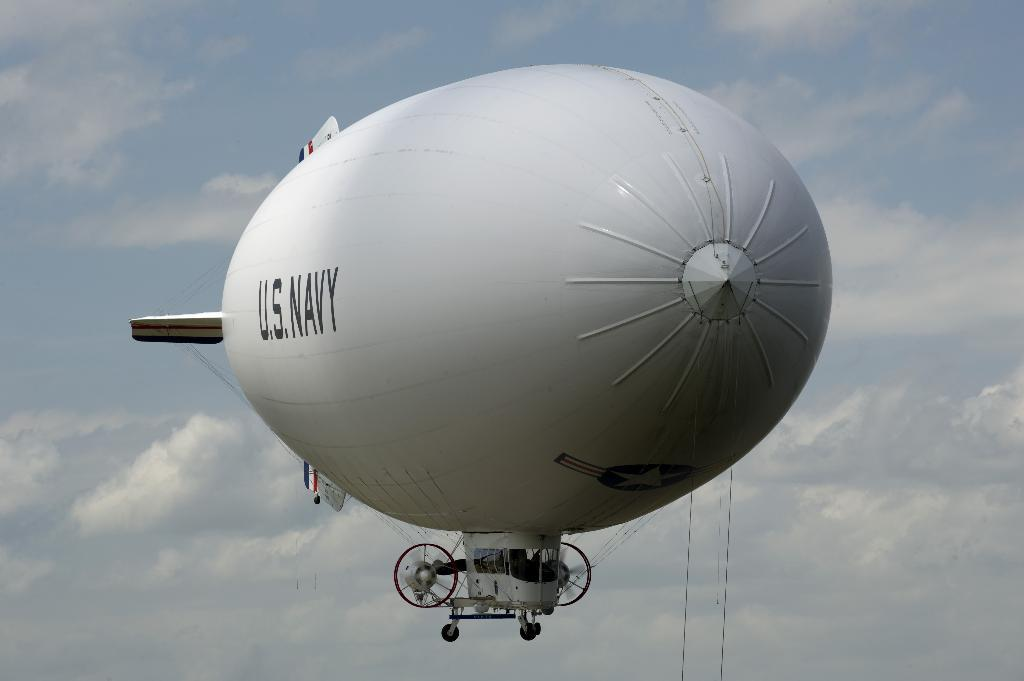<image>
Write a terse but informative summary of the picture. A large white blimp with U.S. Navy emblazoned along the side. 